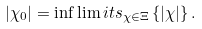Convert formula to latex. <formula><loc_0><loc_0><loc_500><loc_500>\left | \chi _ { 0 } \right | = \inf \lim i t s _ { \chi \in \Xi } \left \{ \left | \chi \right | \right \} .</formula> 